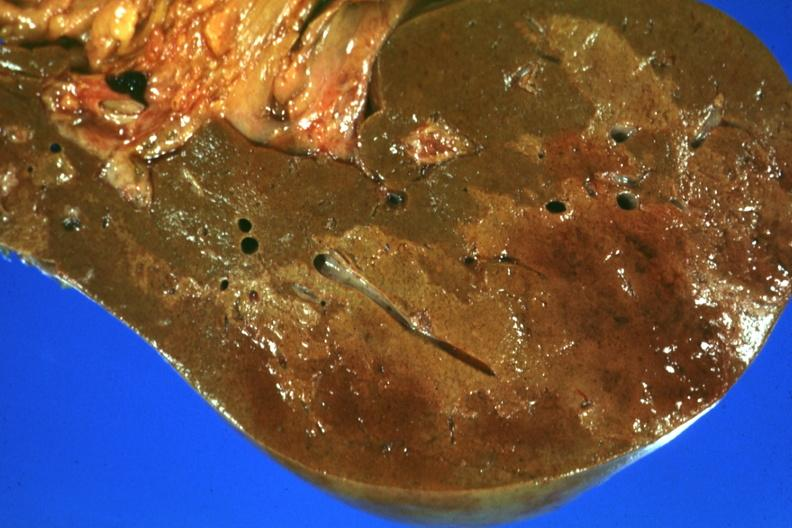what does this image show?
Answer the question using a single word or phrase. Frontal section with large patch of central infarction well seen 